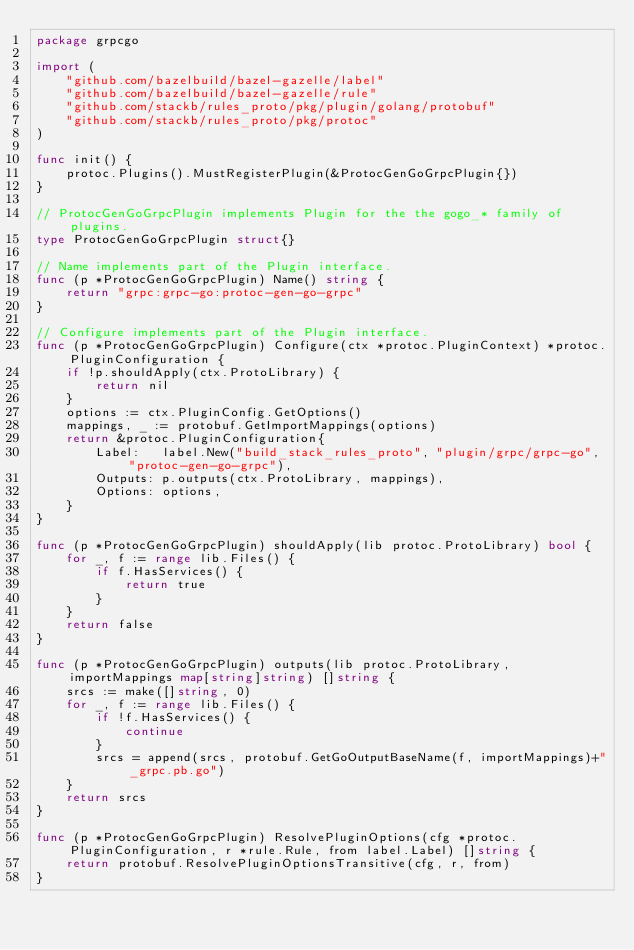Convert code to text. <code><loc_0><loc_0><loc_500><loc_500><_Go_>package grpcgo

import (
	"github.com/bazelbuild/bazel-gazelle/label"
	"github.com/bazelbuild/bazel-gazelle/rule"
	"github.com/stackb/rules_proto/pkg/plugin/golang/protobuf"
	"github.com/stackb/rules_proto/pkg/protoc"
)

func init() {
	protoc.Plugins().MustRegisterPlugin(&ProtocGenGoGrpcPlugin{})
}

// ProtocGenGoGrpcPlugin implements Plugin for the the gogo_* family of plugins.
type ProtocGenGoGrpcPlugin struct{}

// Name implements part of the Plugin interface.
func (p *ProtocGenGoGrpcPlugin) Name() string {
	return "grpc:grpc-go:protoc-gen-go-grpc"
}

// Configure implements part of the Plugin interface.
func (p *ProtocGenGoGrpcPlugin) Configure(ctx *protoc.PluginContext) *protoc.PluginConfiguration {
	if !p.shouldApply(ctx.ProtoLibrary) {
		return nil
	}
	options := ctx.PluginConfig.GetOptions()
	mappings, _ := protobuf.GetImportMappings(options)
	return &protoc.PluginConfiguration{
		Label:   label.New("build_stack_rules_proto", "plugin/grpc/grpc-go", "protoc-gen-go-grpc"),
		Outputs: p.outputs(ctx.ProtoLibrary, mappings),
		Options: options,
	}
}

func (p *ProtocGenGoGrpcPlugin) shouldApply(lib protoc.ProtoLibrary) bool {
	for _, f := range lib.Files() {
		if f.HasServices() {
			return true
		}
	}
	return false
}

func (p *ProtocGenGoGrpcPlugin) outputs(lib protoc.ProtoLibrary, importMappings map[string]string) []string {
	srcs := make([]string, 0)
	for _, f := range lib.Files() {
		if !f.HasServices() {
			continue
		}
		srcs = append(srcs, protobuf.GetGoOutputBaseName(f, importMappings)+"_grpc.pb.go")
	}
	return srcs
}

func (p *ProtocGenGoGrpcPlugin) ResolvePluginOptions(cfg *protoc.PluginConfiguration, r *rule.Rule, from label.Label) []string {
	return protobuf.ResolvePluginOptionsTransitive(cfg, r, from)
}
</code> 